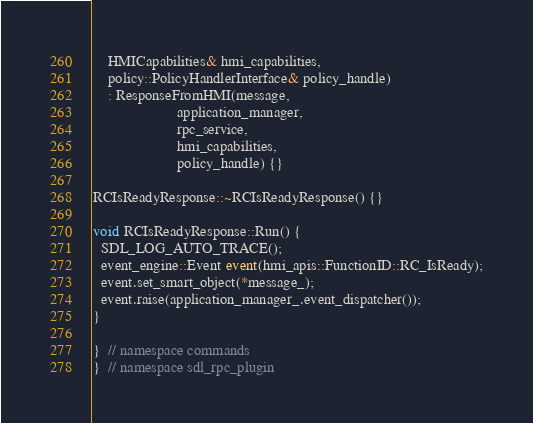Convert code to text. <code><loc_0><loc_0><loc_500><loc_500><_C++_>    HMICapabilities& hmi_capabilities,
    policy::PolicyHandlerInterface& policy_handle)
    : ResponseFromHMI(message,
                      application_manager,
                      rpc_service,
                      hmi_capabilities,
                      policy_handle) {}

RCIsReadyResponse::~RCIsReadyResponse() {}

void RCIsReadyResponse::Run() {
  SDL_LOG_AUTO_TRACE();
  event_engine::Event event(hmi_apis::FunctionID::RC_IsReady);
  event.set_smart_object(*message_);
  event.raise(application_manager_.event_dispatcher());
}

}  // namespace commands
}  // namespace sdl_rpc_plugin
</code> 